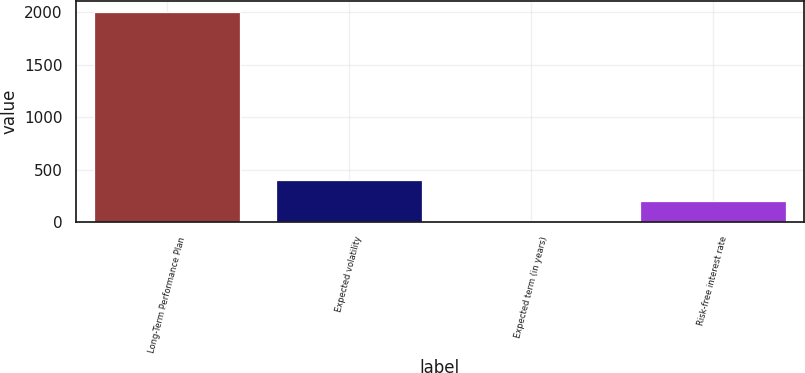<chart> <loc_0><loc_0><loc_500><loc_500><bar_chart><fcel>Long-Term Performance Plan<fcel>Expected volatility<fcel>Expected term (in years)<fcel>Risk-free interest rate<nl><fcel>2006<fcel>402.8<fcel>2<fcel>202.4<nl></chart> 